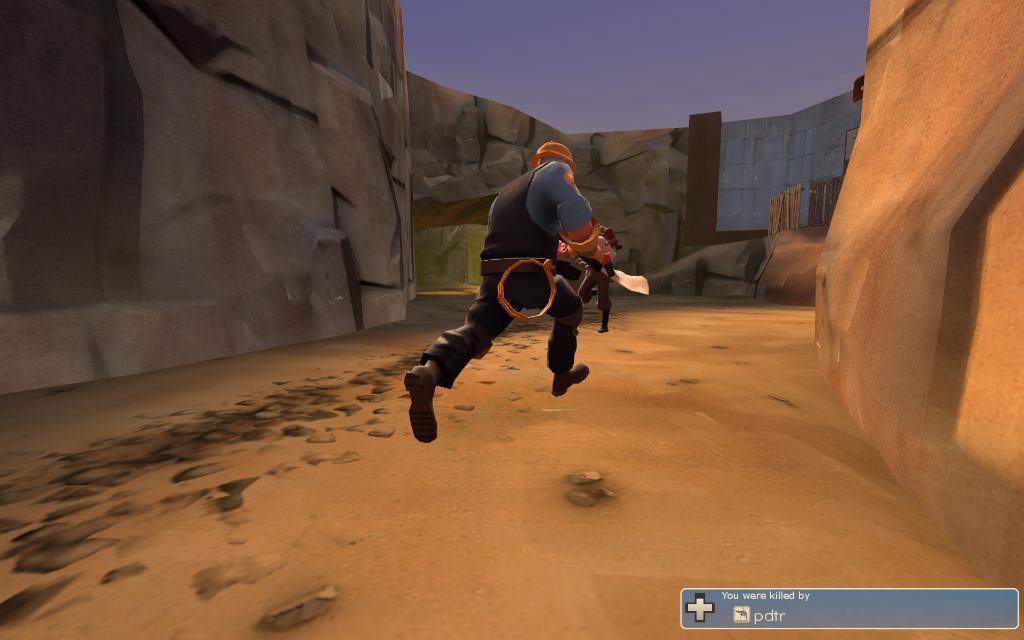Can you describe this image briefly? This is an animated picture where we can see a man is running, behind him rock walls are there. Right bottom of the image some text is present. 